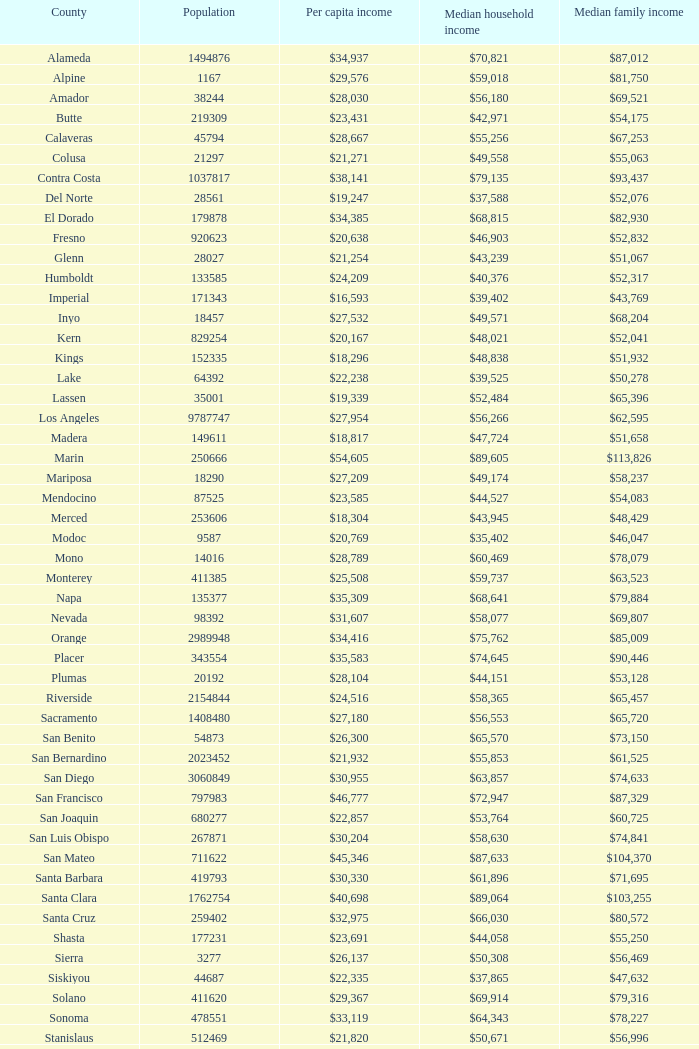What is the median household income of sacramento? $56,553. 